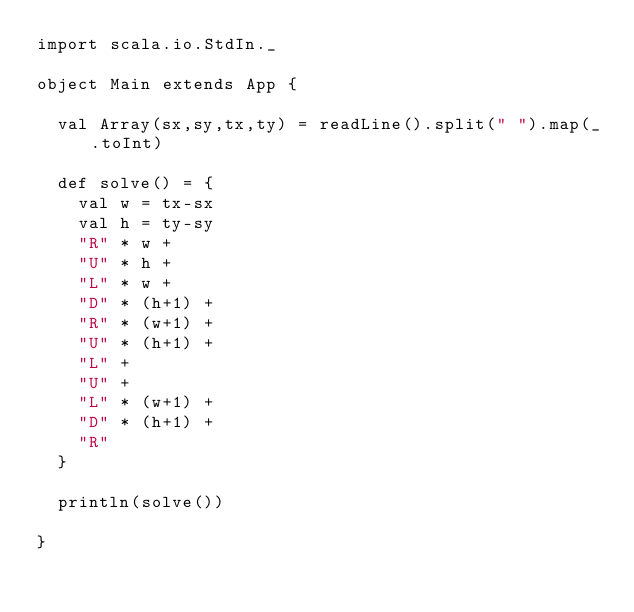Convert code to text. <code><loc_0><loc_0><loc_500><loc_500><_Scala_>import scala.io.StdIn._

object Main extends App {

  val Array(sx,sy,tx,ty) = readLine().split(" ").map(_.toInt)

  def solve() = {
    val w = tx-sx
    val h = ty-sy
    "R" * w +
    "U" * h +
    "L" * w +
    "D" * (h+1) +
    "R" * (w+1) +
    "U" * (h+1) +
    "L" +
    "U" +
    "L" * (w+1) +
    "D" * (h+1) +
    "R"
  }

  println(solve())

}

</code> 